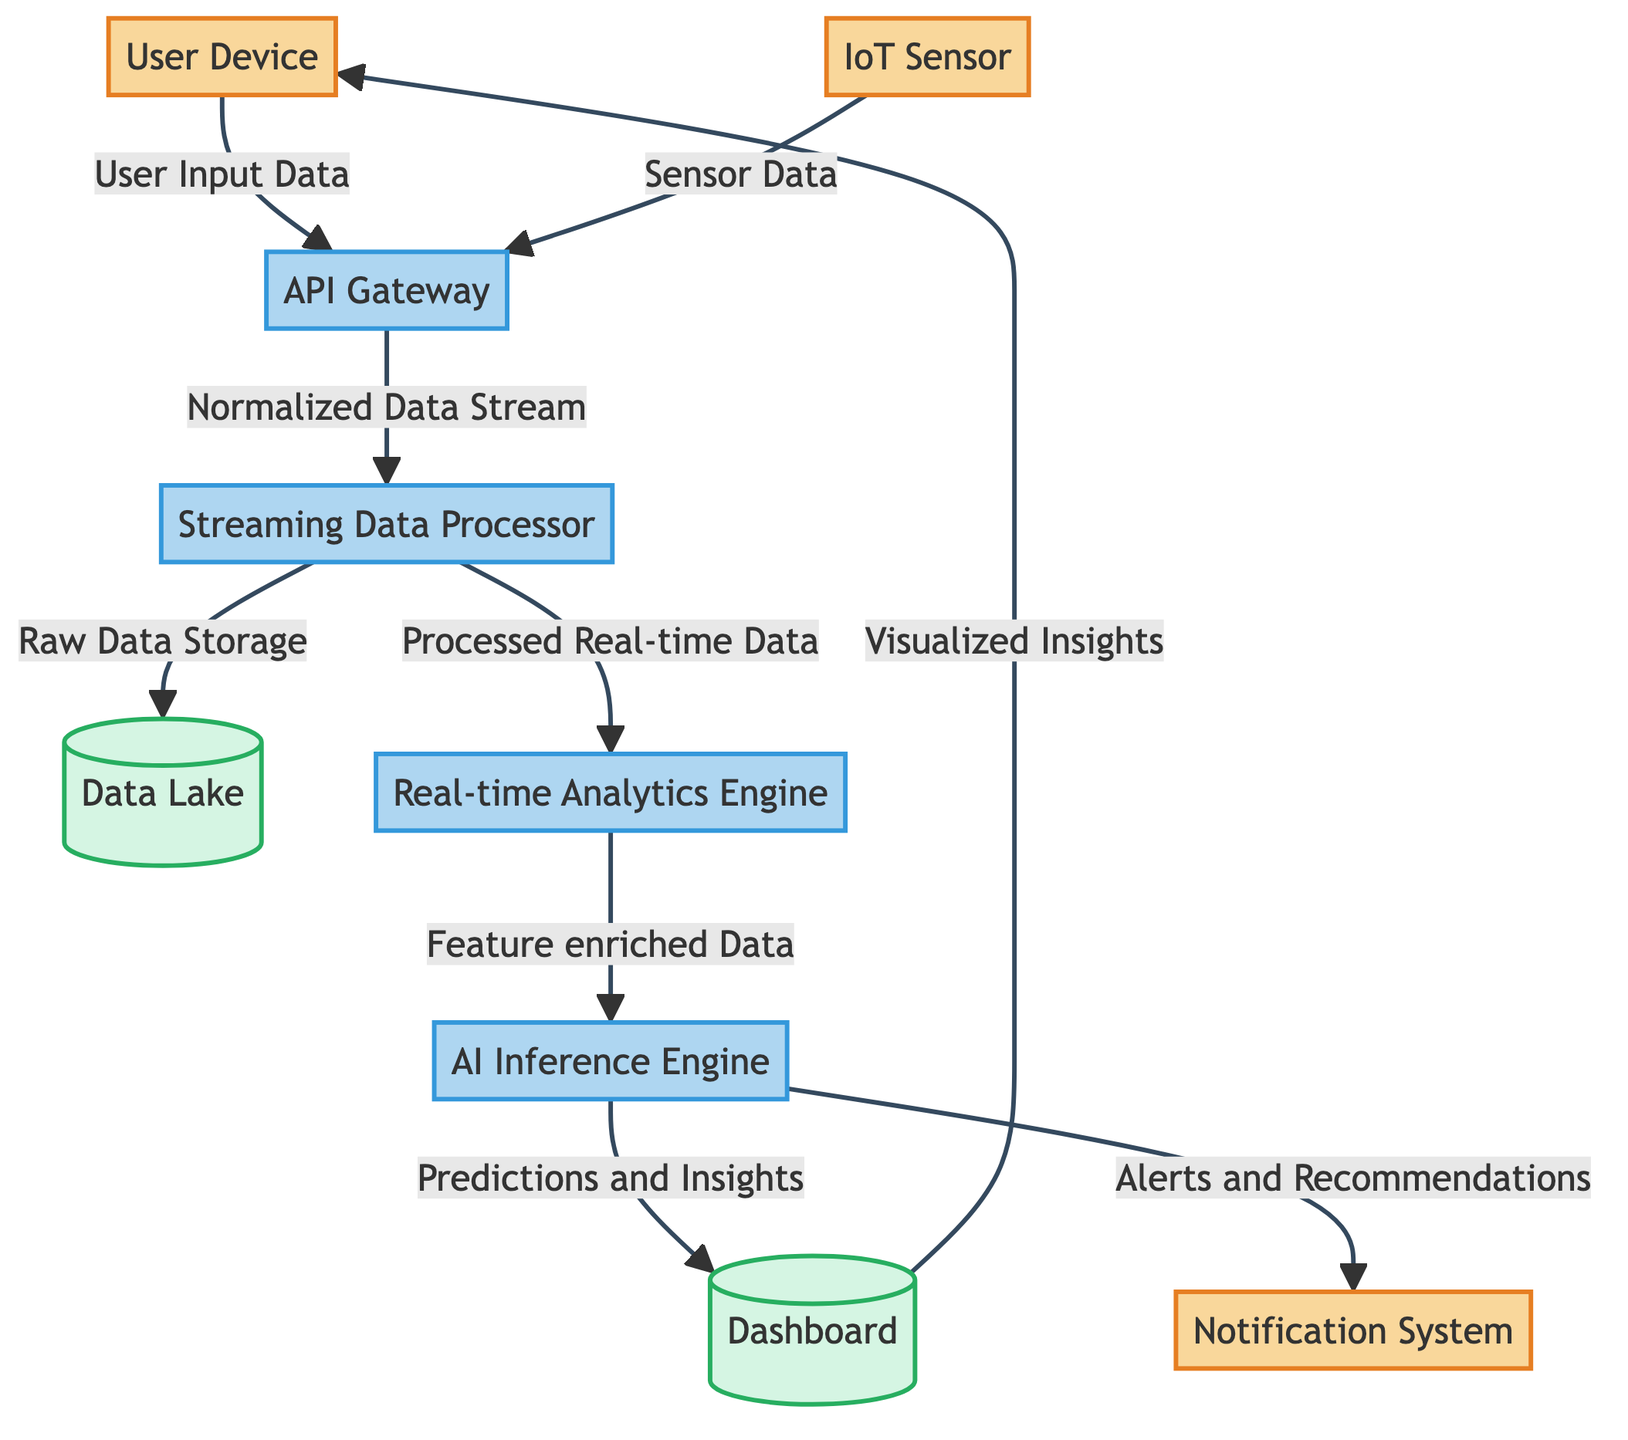What are the external entities in the diagram? The diagram identifies three external entities: User Device, IoT Sensor, and Notification System. They are categorized as External Entities representing external data sources or users.
Answer: User Device, IoT Sensor, Notification System How many processes are represented in the diagram? There are five processes depicted in the diagram: API Gateway, Streaming Data Processor, Real-time Analytics Engine, AI Inference Engine, and they are responsible for data handling and transformation.
Answer: Five What type of data flows from the API Gateway to the Streaming Data Processor? The data flowing from the API Gateway to the Streaming Data Processor is classified as "Normalized Data Stream", which indicates the data has been standardized for further processing.
Answer: Normalized Data Stream Which process receives "Feature enriched Data"? The Real-time Analytics Engine sends the "Feature enriched Data" to the AI Inference Engine for further analysis and insight generation. This step is crucial for preparing data for predictive modeling.
Answer: AI Inference Engine What data does the Dashboard send back to the User Device? The Dashboard presents the "Visualized Insights" back to the User Device, which indicates a completed cycle of data processing aimed at providing informative outputs to users.
Answer: Visualized Insights What is the relationship between the AI Inference Engine and the Notification System? The AI Inference Engine sends "Alerts and Recommendations" to the Notification System, showcasing a link where processed data leads to actionable outcomes communicated to users.
Answer: Alerts and Recommendations What type of data is stored in the Data Lake? The data stored in the Data Lake is referred to as "Raw Data Storage", indicating it acts as a repository for unprocessed data to be used for future analytics.
Answer: Raw Data Storage How many data flows are there in total in the diagram? The total number of data flows represented in the diagram is eight, connecting various entities and processes, illustrating how data travels from input to output.
Answer: Eight What is the first data input into the system? The system first receives data labeled as "User Input Data" from the User Device, which initiates the data processing workflow in the diagram.
Answer: User Input Data 